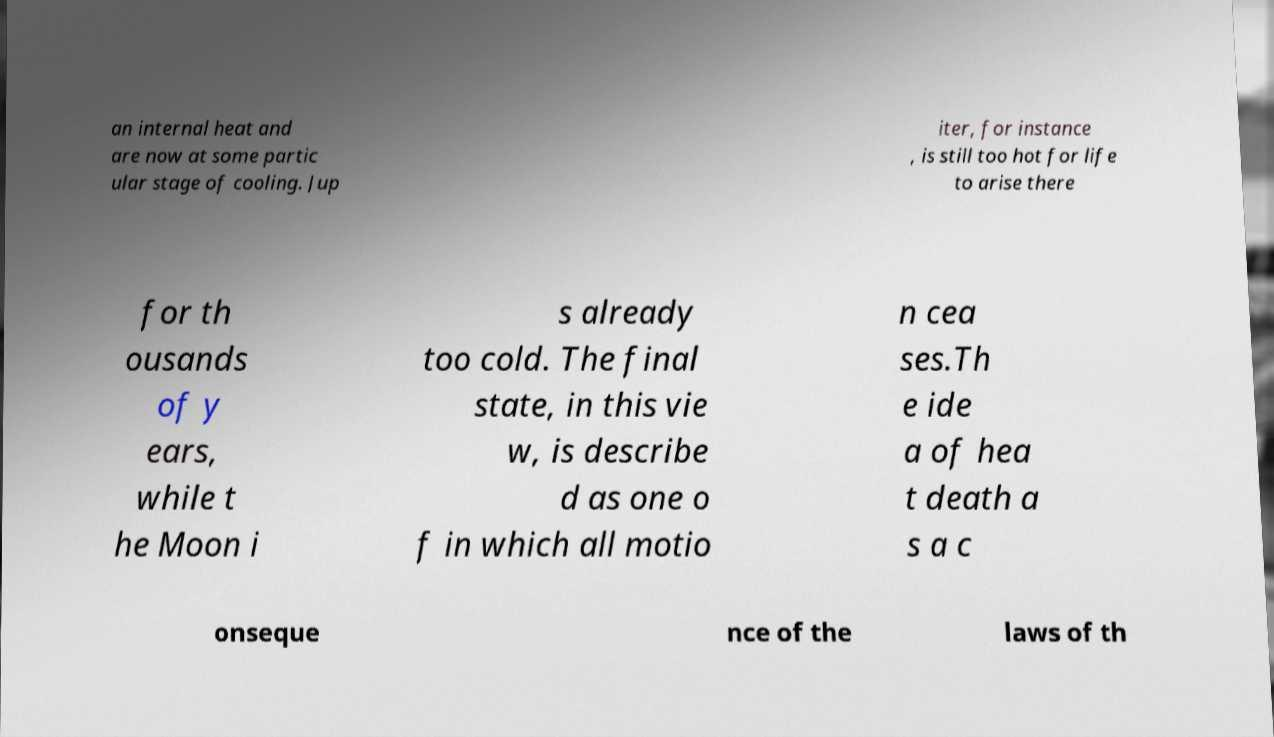Could you assist in decoding the text presented in this image and type it out clearly? an internal heat and are now at some partic ular stage of cooling. Jup iter, for instance , is still too hot for life to arise there for th ousands of y ears, while t he Moon i s already too cold. The final state, in this vie w, is describe d as one o f in which all motio n cea ses.Th e ide a of hea t death a s a c onseque nce of the laws of th 